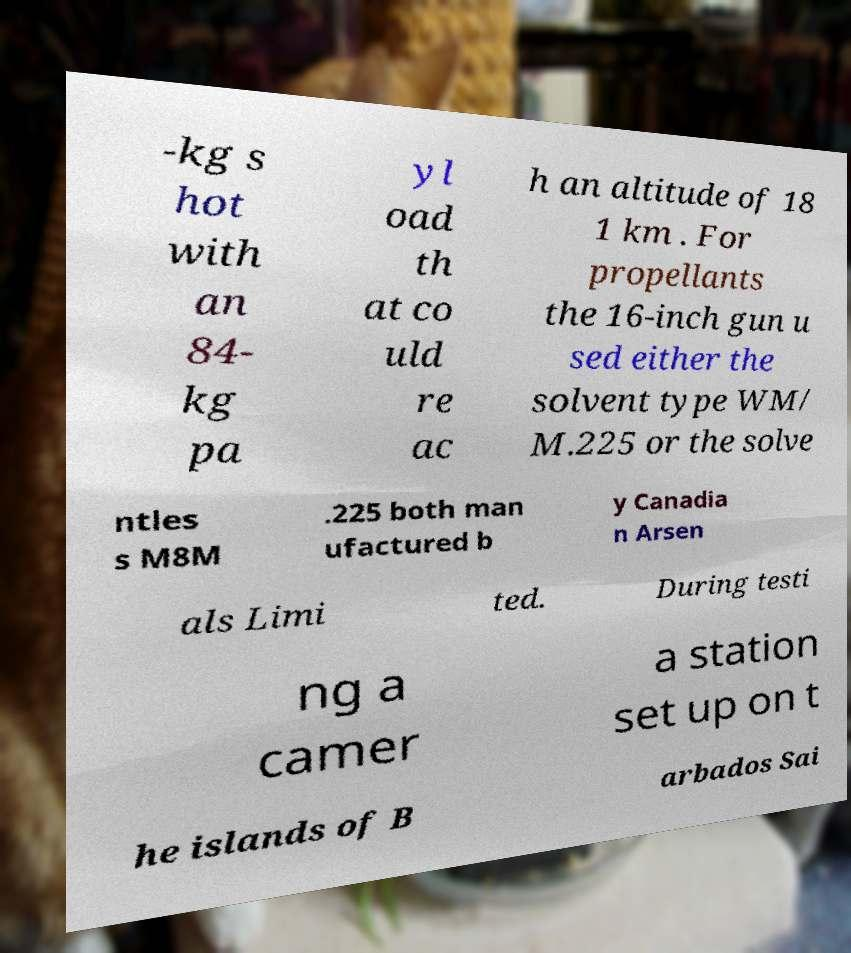Please identify and transcribe the text found in this image. -kg s hot with an 84- kg pa yl oad th at co uld re ac h an altitude of 18 1 km . For propellants the 16-inch gun u sed either the solvent type WM/ M.225 or the solve ntles s M8M .225 both man ufactured b y Canadia n Arsen als Limi ted. During testi ng a camer a station set up on t he islands of B arbados Sai 